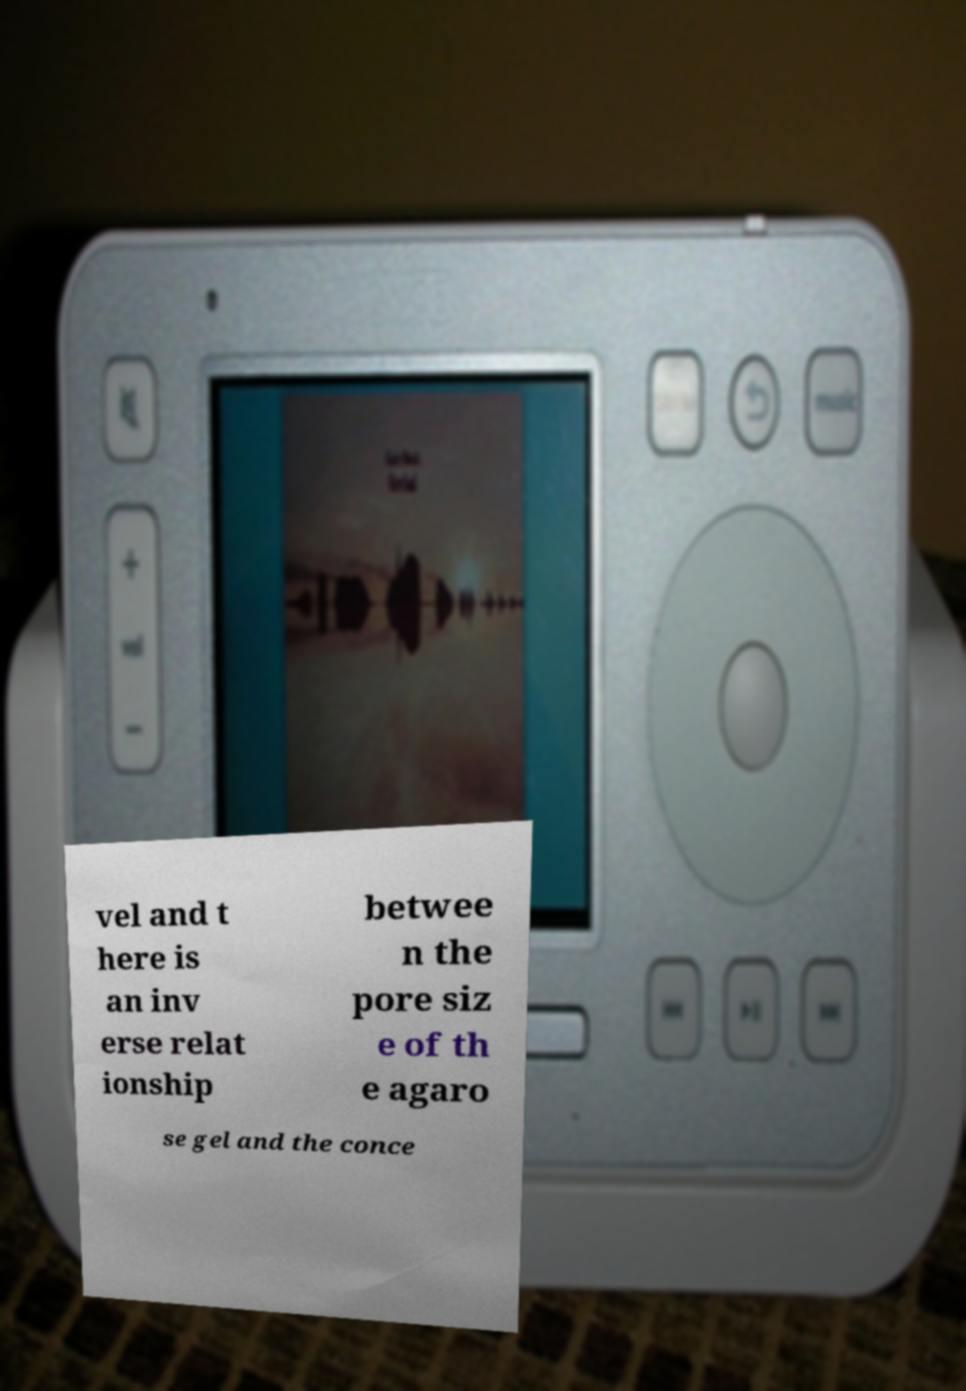Please read and relay the text visible in this image. What does it say? vel and t here is an inv erse relat ionship betwee n the pore siz e of th e agaro se gel and the conce 